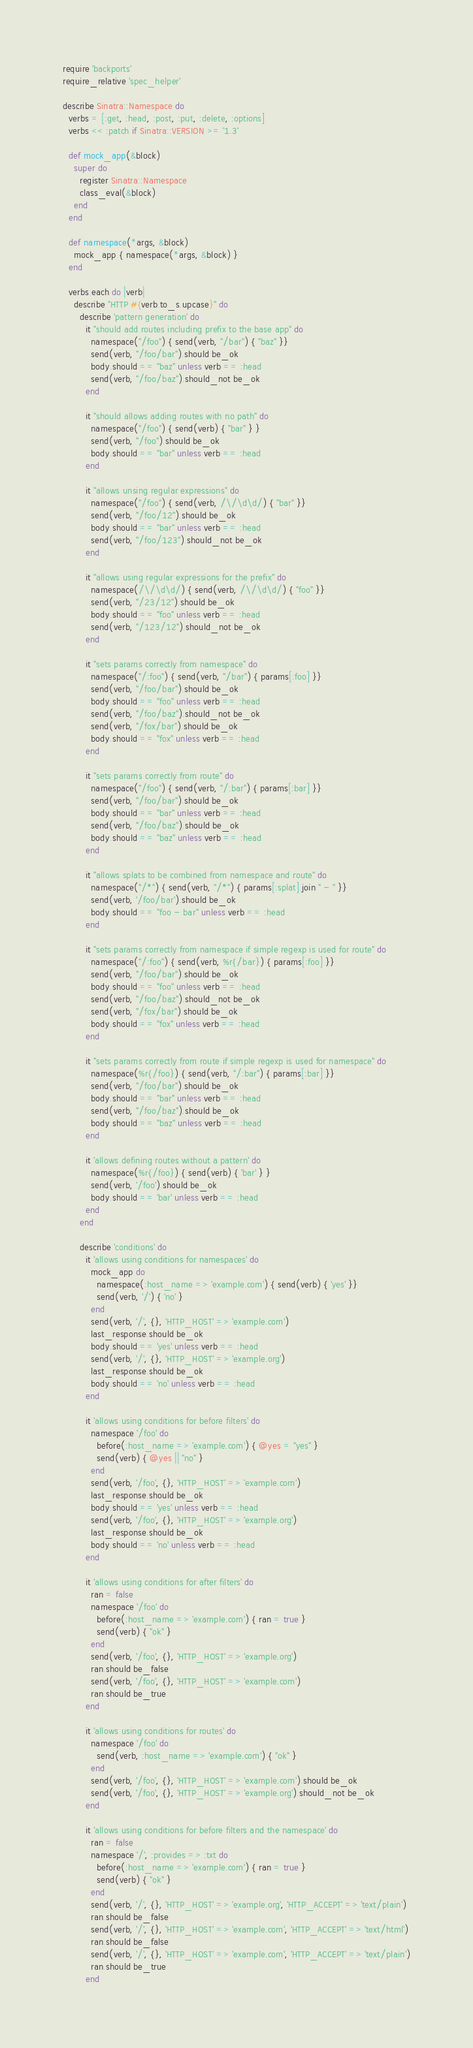Convert code to text. <code><loc_0><loc_0><loc_500><loc_500><_Ruby_>require 'backports'
require_relative 'spec_helper'

describe Sinatra::Namespace do
  verbs = [:get, :head, :post, :put, :delete, :options]
  verbs << :patch if Sinatra::VERSION >= '1.3'

  def mock_app(&block)
    super do
      register Sinatra::Namespace
      class_eval(&block)
    end
  end

  def namespace(*args, &block)
    mock_app { namespace(*args, &block) }
  end

  verbs.each do |verb|
    describe "HTTP #{verb.to_s.upcase}" do
      describe 'pattern generation' do
        it "should add routes including prefix to the base app" do
          namespace("/foo") { send(verb, "/bar") { "baz" }}
          send(verb, "/foo/bar").should be_ok
          body.should == "baz" unless verb == :head
          send(verb, "/foo/baz").should_not be_ok
        end

        it "should allows adding routes with no path" do
          namespace("/foo") { send(verb) { "bar" } }
          send(verb, "/foo").should be_ok
          body.should == "bar" unless verb == :head
        end

        it "allows unsing regular expressions" do
          namespace("/foo") { send(verb, /\/\d\d/) { "bar" }}
          send(verb, "/foo/12").should be_ok
          body.should == "bar" unless verb == :head
          send(verb, "/foo/123").should_not be_ok
        end

        it "allows using regular expressions for the prefix" do
          namespace(/\/\d\d/) { send(verb, /\/\d\d/) { "foo" }}
          send(verb, "/23/12").should be_ok
          body.should == "foo" unless verb == :head
          send(verb, "/123/12").should_not be_ok
        end

        it "sets params correctly from namespace" do
          namespace("/:foo") { send(verb, "/bar") { params[:foo] }}
          send(verb, "/foo/bar").should be_ok
          body.should == "foo" unless verb == :head
          send(verb, "/foo/baz").should_not be_ok
          send(verb, "/fox/bar").should be_ok
          body.should == "fox" unless verb == :head
        end
  
        it "sets params correctly from route" do
          namespace("/foo") { send(verb, "/:bar") { params[:bar] }}
          send(verb, "/foo/bar").should be_ok
          body.should == "bar" unless verb == :head
          send(verb, "/foo/baz").should be_ok
          body.should == "baz" unless verb == :head
        end

        it "allows splats to be combined from namespace and route" do
          namespace("/*") { send(verb, "/*") { params[:splat].join " - " }}
          send(verb, '/foo/bar').should be_ok
          body.should == "foo - bar" unless verb == :head
        end

        it "sets params correctly from namespace if simple regexp is used for route" do
          namespace("/:foo") { send(verb, %r{/bar}) { params[:foo] }}
          send(verb, "/foo/bar").should be_ok
          body.should == "foo" unless verb == :head
          send(verb, "/foo/baz").should_not be_ok
          send(verb, "/fox/bar").should be_ok
          body.should == "fox" unless verb == :head
        end

        it "sets params correctly from route if simple regexp is used for namespace" do
          namespace(%r{/foo}) { send(verb, "/:bar") { params[:bar] }}
          send(verb, "/foo/bar").should be_ok
          body.should == "bar" unless verb == :head
          send(verb, "/foo/baz").should be_ok
          body.should == "baz" unless verb == :head
        end

        it 'allows defining routes without a pattern' do
          namespace(%r{/foo}) { send(verb) { 'bar' } }
          send(verb, '/foo').should be_ok
          body.should == 'bar' unless verb == :head 
        end
      end

      describe 'conditions' do
        it 'allows using conditions for namespaces' do
          mock_app do
            namespace(:host_name => 'example.com') { send(verb) { 'yes' }}
            send(verb, '/') { 'no' }
          end
          send(verb, '/', {}, 'HTTP_HOST' => 'example.com')
          last_response.should be_ok
          body.should == 'yes' unless verb == :head
          send(verb, '/', {}, 'HTTP_HOST' => 'example.org')
          last_response.should be_ok
          body.should == 'no' unless verb == :head
        end

        it 'allows using conditions for before filters' do
          namespace '/foo' do
            before(:host_name => 'example.com') { @yes = "yes" }
            send(verb) { @yes || "no" }
          end
          send(verb, '/foo', {}, 'HTTP_HOST' => 'example.com')
          last_response.should be_ok
          body.should == 'yes' unless verb == :head
          send(verb, '/foo', {}, 'HTTP_HOST' => 'example.org')
          last_response.should be_ok
          body.should == 'no' unless verb == :head
        end

        it 'allows using conditions for after filters' do
          ran = false
          namespace '/foo' do
            before(:host_name => 'example.com') { ran = true }
            send(verb) { "ok" }
          end
          send(verb, '/foo', {}, 'HTTP_HOST' => 'example.org')
          ran.should be_false
          send(verb, '/foo', {}, 'HTTP_HOST' => 'example.com')
          ran.should be_true
        end

        it 'allows using conditions for routes' do
          namespace '/foo' do
            send(verb, :host_name => 'example.com') { "ok" }
          end
          send(verb, '/foo', {}, 'HTTP_HOST' => 'example.com').should be_ok
          send(verb, '/foo', {}, 'HTTP_HOST' => 'example.org').should_not be_ok
        end

        it 'allows using conditions for before filters and the namespace' do
          ran = false
          namespace '/', :provides => :txt do
            before(:host_name => 'example.com') { ran = true }
            send(verb) { "ok" }
          end
          send(verb, '/', {}, 'HTTP_HOST' => 'example.org', 'HTTP_ACCEPT' => 'text/plain')
          ran.should be_false
          send(verb, '/', {}, 'HTTP_HOST' => 'example.com', 'HTTP_ACCEPT' => 'text/html')
          ran.should be_false
          send(verb, '/', {}, 'HTTP_HOST' => 'example.com', 'HTTP_ACCEPT' => 'text/plain')
          ran.should be_true
        end
</code> 